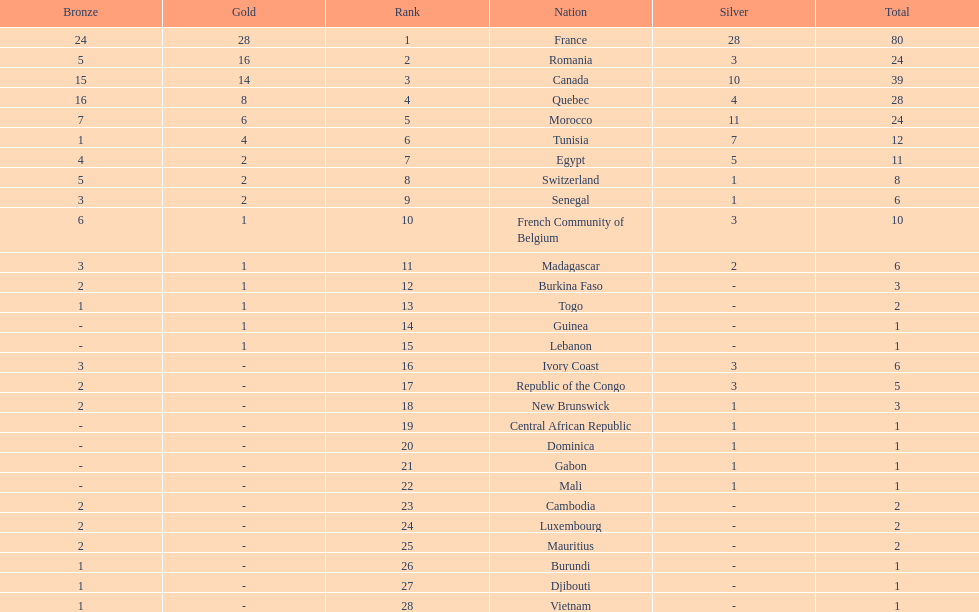How many nations won at least 10 medals? 8. 